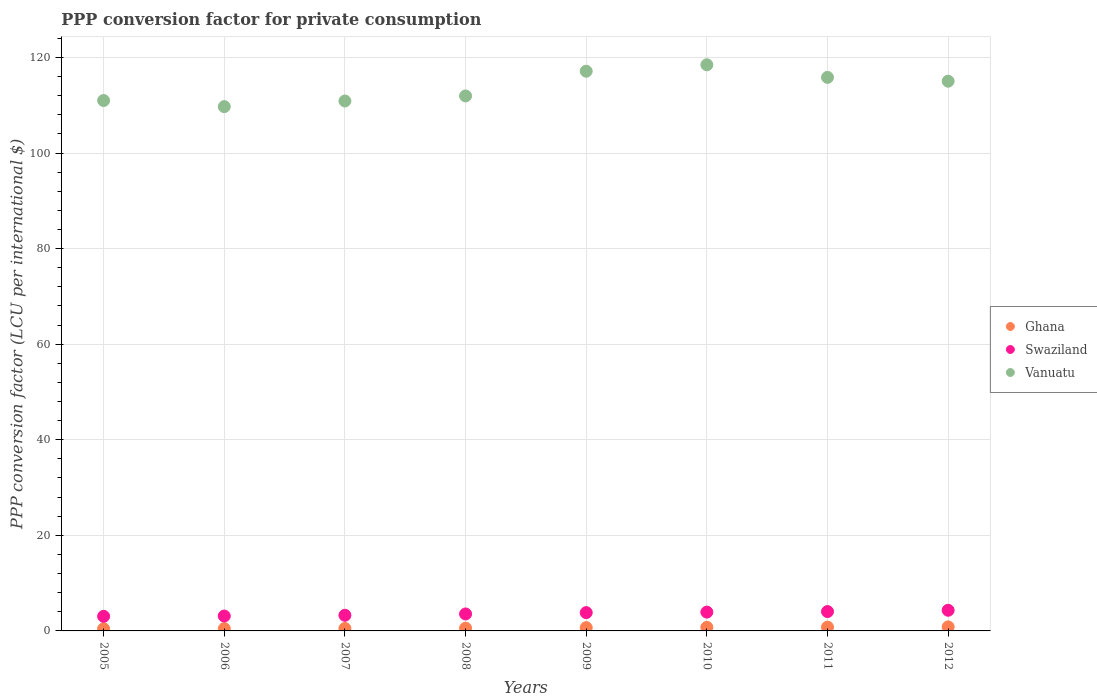Is the number of dotlines equal to the number of legend labels?
Make the answer very short. Yes. What is the PPP conversion factor for private consumption in Ghana in 2009?
Your answer should be very brief. 0.69. Across all years, what is the maximum PPP conversion factor for private consumption in Swaziland?
Your response must be concise. 4.32. Across all years, what is the minimum PPP conversion factor for private consumption in Ghana?
Your response must be concise. 0.44. In which year was the PPP conversion factor for private consumption in Swaziland minimum?
Offer a very short reply. 2005. What is the total PPP conversion factor for private consumption in Swaziland in the graph?
Offer a very short reply. 29.13. What is the difference between the PPP conversion factor for private consumption in Vanuatu in 2005 and that in 2011?
Provide a short and direct response. -4.85. What is the difference between the PPP conversion factor for private consumption in Swaziland in 2006 and the PPP conversion factor for private consumption in Ghana in 2005?
Your answer should be compact. 2.67. What is the average PPP conversion factor for private consumption in Swaziland per year?
Provide a short and direct response. 3.64. In the year 2011, what is the difference between the PPP conversion factor for private consumption in Ghana and PPP conversion factor for private consumption in Vanuatu?
Give a very brief answer. -115.04. In how many years, is the PPP conversion factor for private consumption in Swaziland greater than 36 LCU?
Your answer should be very brief. 0. What is the ratio of the PPP conversion factor for private consumption in Vanuatu in 2006 to that in 2012?
Your answer should be very brief. 0.95. What is the difference between the highest and the second highest PPP conversion factor for private consumption in Ghana?
Keep it short and to the point. 0.05. What is the difference between the highest and the lowest PPP conversion factor for private consumption in Swaziland?
Ensure brevity in your answer.  1.27. In how many years, is the PPP conversion factor for private consumption in Vanuatu greater than the average PPP conversion factor for private consumption in Vanuatu taken over all years?
Give a very brief answer. 4. Is it the case that in every year, the sum of the PPP conversion factor for private consumption in Ghana and PPP conversion factor for private consumption in Swaziland  is greater than the PPP conversion factor for private consumption in Vanuatu?
Give a very brief answer. No. Does the PPP conversion factor for private consumption in Ghana monotonically increase over the years?
Make the answer very short. Yes. Is the PPP conversion factor for private consumption in Vanuatu strictly greater than the PPP conversion factor for private consumption in Swaziland over the years?
Provide a succinct answer. Yes. Is the PPP conversion factor for private consumption in Swaziland strictly less than the PPP conversion factor for private consumption in Vanuatu over the years?
Your answer should be very brief. Yes. How many dotlines are there?
Offer a terse response. 3. Does the graph contain grids?
Ensure brevity in your answer.  Yes. Where does the legend appear in the graph?
Keep it short and to the point. Center right. How many legend labels are there?
Provide a succinct answer. 3. What is the title of the graph?
Provide a short and direct response. PPP conversion factor for private consumption. What is the label or title of the Y-axis?
Keep it short and to the point. PPP conversion factor (LCU per international $). What is the PPP conversion factor (LCU per international $) in Ghana in 2005?
Your answer should be compact. 0.44. What is the PPP conversion factor (LCU per international $) of Swaziland in 2005?
Provide a succinct answer. 3.05. What is the PPP conversion factor (LCU per international $) in Vanuatu in 2005?
Provide a short and direct response. 110.98. What is the PPP conversion factor (LCU per international $) of Ghana in 2006?
Provide a short and direct response. 0.47. What is the PPP conversion factor (LCU per international $) of Swaziland in 2006?
Offer a very short reply. 3.11. What is the PPP conversion factor (LCU per international $) of Vanuatu in 2006?
Offer a terse response. 109.71. What is the PPP conversion factor (LCU per international $) of Ghana in 2007?
Provide a succinct answer. 0.51. What is the PPP conversion factor (LCU per international $) of Swaziland in 2007?
Give a very brief answer. 3.27. What is the PPP conversion factor (LCU per international $) of Vanuatu in 2007?
Offer a very short reply. 110.88. What is the PPP conversion factor (LCU per international $) in Ghana in 2008?
Offer a very short reply. 0.57. What is the PPP conversion factor (LCU per international $) in Swaziland in 2008?
Give a very brief answer. 3.55. What is the PPP conversion factor (LCU per international $) in Vanuatu in 2008?
Make the answer very short. 111.94. What is the PPP conversion factor (LCU per international $) of Ghana in 2009?
Offer a terse response. 0.69. What is the PPP conversion factor (LCU per international $) of Swaziland in 2009?
Provide a short and direct response. 3.83. What is the PPP conversion factor (LCU per international $) of Vanuatu in 2009?
Offer a very short reply. 117.11. What is the PPP conversion factor (LCU per international $) of Ghana in 2010?
Your answer should be very brief. 0.75. What is the PPP conversion factor (LCU per international $) of Swaziland in 2010?
Your answer should be very brief. 3.94. What is the PPP conversion factor (LCU per international $) in Vanuatu in 2010?
Your answer should be very brief. 118.46. What is the PPP conversion factor (LCU per international $) of Ghana in 2011?
Your answer should be very brief. 0.79. What is the PPP conversion factor (LCU per international $) of Swaziland in 2011?
Make the answer very short. 4.05. What is the PPP conversion factor (LCU per international $) in Vanuatu in 2011?
Make the answer very short. 115.83. What is the PPP conversion factor (LCU per international $) in Ghana in 2012?
Your response must be concise. 0.84. What is the PPP conversion factor (LCU per international $) of Swaziland in 2012?
Provide a succinct answer. 4.32. What is the PPP conversion factor (LCU per international $) of Vanuatu in 2012?
Provide a succinct answer. 115.03. Across all years, what is the maximum PPP conversion factor (LCU per international $) of Ghana?
Offer a terse response. 0.84. Across all years, what is the maximum PPP conversion factor (LCU per international $) in Swaziland?
Keep it short and to the point. 4.32. Across all years, what is the maximum PPP conversion factor (LCU per international $) in Vanuatu?
Provide a short and direct response. 118.46. Across all years, what is the minimum PPP conversion factor (LCU per international $) of Ghana?
Your answer should be compact. 0.44. Across all years, what is the minimum PPP conversion factor (LCU per international $) of Swaziland?
Give a very brief answer. 3.05. Across all years, what is the minimum PPP conversion factor (LCU per international $) of Vanuatu?
Offer a very short reply. 109.71. What is the total PPP conversion factor (LCU per international $) in Ghana in the graph?
Keep it short and to the point. 5.07. What is the total PPP conversion factor (LCU per international $) in Swaziland in the graph?
Provide a succinct answer. 29.13. What is the total PPP conversion factor (LCU per international $) of Vanuatu in the graph?
Keep it short and to the point. 909.94. What is the difference between the PPP conversion factor (LCU per international $) of Ghana in 2005 and that in 2006?
Make the answer very short. -0.03. What is the difference between the PPP conversion factor (LCU per international $) of Swaziland in 2005 and that in 2006?
Your answer should be compact. -0.06. What is the difference between the PPP conversion factor (LCU per international $) in Vanuatu in 2005 and that in 2006?
Provide a short and direct response. 1.27. What is the difference between the PPP conversion factor (LCU per international $) of Ghana in 2005 and that in 2007?
Your response must be concise. -0.07. What is the difference between the PPP conversion factor (LCU per international $) of Swaziland in 2005 and that in 2007?
Provide a short and direct response. -0.22. What is the difference between the PPP conversion factor (LCU per international $) of Vanuatu in 2005 and that in 2007?
Give a very brief answer. 0.1. What is the difference between the PPP conversion factor (LCU per international $) in Ghana in 2005 and that in 2008?
Make the answer very short. -0.13. What is the difference between the PPP conversion factor (LCU per international $) of Swaziland in 2005 and that in 2008?
Keep it short and to the point. -0.5. What is the difference between the PPP conversion factor (LCU per international $) in Vanuatu in 2005 and that in 2008?
Keep it short and to the point. -0.96. What is the difference between the PPP conversion factor (LCU per international $) of Ghana in 2005 and that in 2009?
Your response must be concise. -0.24. What is the difference between the PPP conversion factor (LCU per international $) in Swaziland in 2005 and that in 2009?
Keep it short and to the point. -0.78. What is the difference between the PPP conversion factor (LCU per international $) in Vanuatu in 2005 and that in 2009?
Provide a succinct answer. -6.13. What is the difference between the PPP conversion factor (LCU per international $) in Ghana in 2005 and that in 2010?
Your response must be concise. -0.31. What is the difference between the PPP conversion factor (LCU per international $) of Swaziland in 2005 and that in 2010?
Offer a very short reply. -0.88. What is the difference between the PPP conversion factor (LCU per international $) of Vanuatu in 2005 and that in 2010?
Provide a short and direct response. -7.48. What is the difference between the PPP conversion factor (LCU per international $) in Ghana in 2005 and that in 2011?
Your response must be concise. -0.35. What is the difference between the PPP conversion factor (LCU per international $) of Swaziland in 2005 and that in 2011?
Offer a terse response. -1. What is the difference between the PPP conversion factor (LCU per international $) of Vanuatu in 2005 and that in 2011?
Make the answer very short. -4.85. What is the difference between the PPP conversion factor (LCU per international $) of Ghana in 2005 and that in 2012?
Offer a terse response. -0.4. What is the difference between the PPP conversion factor (LCU per international $) of Swaziland in 2005 and that in 2012?
Your response must be concise. -1.27. What is the difference between the PPP conversion factor (LCU per international $) of Vanuatu in 2005 and that in 2012?
Your answer should be compact. -4.05. What is the difference between the PPP conversion factor (LCU per international $) of Ghana in 2006 and that in 2007?
Provide a short and direct response. -0.04. What is the difference between the PPP conversion factor (LCU per international $) of Swaziland in 2006 and that in 2007?
Give a very brief answer. -0.16. What is the difference between the PPP conversion factor (LCU per international $) in Vanuatu in 2006 and that in 2007?
Your answer should be very brief. -1.18. What is the difference between the PPP conversion factor (LCU per international $) in Ghana in 2006 and that in 2008?
Keep it short and to the point. -0.1. What is the difference between the PPP conversion factor (LCU per international $) of Swaziland in 2006 and that in 2008?
Your response must be concise. -0.44. What is the difference between the PPP conversion factor (LCU per international $) in Vanuatu in 2006 and that in 2008?
Ensure brevity in your answer.  -2.23. What is the difference between the PPP conversion factor (LCU per international $) of Ghana in 2006 and that in 2009?
Your answer should be very brief. -0.21. What is the difference between the PPP conversion factor (LCU per international $) of Swaziland in 2006 and that in 2009?
Your answer should be very brief. -0.71. What is the difference between the PPP conversion factor (LCU per international $) of Vanuatu in 2006 and that in 2009?
Give a very brief answer. -7.41. What is the difference between the PPP conversion factor (LCU per international $) in Ghana in 2006 and that in 2010?
Provide a short and direct response. -0.27. What is the difference between the PPP conversion factor (LCU per international $) in Swaziland in 2006 and that in 2010?
Your answer should be very brief. -0.82. What is the difference between the PPP conversion factor (LCU per international $) in Vanuatu in 2006 and that in 2010?
Give a very brief answer. -8.75. What is the difference between the PPP conversion factor (LCU per international $) in Ghana in 2006 and that in 2011?
Make the answer very short. -0.31. What is the difference between the PPP conversion factor (LCU per international $) in Swaziland in 2006 and that in 2011?
Keep it short and to the point. -0.93. What is the difference between the PPP conversion factor (LCU per international $) in Vanuatu in 2006 and that in 2011?
Your response must be concise. -6.12. What is the difference between the PPP conversion factor (LCU per international $) of Ghana in 2006 and that in 2012?
Provide a short and direct response. -0.37. What is the difference between the PPP conversion factor (LCU per international $) of Swaziland in 2006 and that in 2012?
Your answer should be very brief. -1.21. What is the difference between the PPP conversion factor (LCU per international $) of Vanuatu in 2006 and that in 2012?
Your answer should be very brief. -5.32. What is the difference between the PPP conversion factor (LCU per international $) of Ghana in 2007 and that in 2008?
Ensure brevity in your answer.  -0.06. What is the difference between the PPP conversion factor (LCU per international $) in Swaziland in 2007 and that in 2008?
Provide a short and direct response. -0.28. What is the difference between the PPP conversion factor (LCU per international $) in Vanuatu in 2007 and that in 2008?
Ensure brevity in your answer.  -1.06. What is the difference between the PPP conversion factor (LCU per international $) of Ghana in 2007 and that in 2009?
Offer a very short reply. -0.18. What is the difference between the PPP conversion factor (LCU per international $) of Swaziland in 2007 and that in 2009?
Keep it short and to the point. -0.56. What is the difference between the PPP conversion factor (LCU per international $) of Vanuatu in 2007 and that in 2009?
Give a very brief answer. -6.23. What is the difference between the PPP conversion factor (LCU per international $) in Ghana in 2007 and that in 2010?
Make the answer very short. -0.24. What is the difference between the PPP conversion factor (LCU per international $) in Swaziland in 2007 and that in 2010?
Keep it short and to the point. -0.66. What is the difference between the PPP conversion factor (LCU per international $) in Vanuatu in 2007 and that in 2010?
Keep it short and to the point. -7.58. What is the difference between the PPP conversion factor (LCU per international $) of Ghana in 2007 and that in 2011?
Keep it short and to the point. -0.28. What is the difference between the PPP conversion factor (LCU per international $) of Swaziland in 2007 and that in 2011?
Offer a terse response. -0.78. What is the difference between the PPP conversion factor (LCU per international $) in Vanuatu in 2007 and that in 2011?
Provide a succinct answer. -4.94. What is the difference between the PPP conversion factor (LCU per international $) in Ghana in 2007 and that in 2012?
Offer a terse response. -0.33. What is the difference between the PPP conversion factor (LCU per international $) of Swaziland in 2007 and that in 2012?
Offer a terse response. -1.05. What is the difference between the PPP conversion factor (LCU per international $) in Vanuatu in 2007 and that in 2012?
Your answer should be compact. -4.14. What is the difference between the PPP conversion factor (LCU per international $) of Ghana in 2008 and that in 2009?
Ensure brevity in your answer.  -0.11. What is the difference between the PPP conversion factor (LCU per international $) of Swaziland in 2008 and that in 2009?
Your answer should be compact. -0.28. What is the difference between the PPP conversion factor (LCU per international $) in Vanuatu in 2008 and that in 2009?
Provide a succinct answer. -5.17. What is the difference between the PPP conversion factor (LCU per international $) of Ghana in 2008 and that in 2010?
Your answer should be compact. -0.17. What is the difference between the PPP conversion factor (LCU per international $) in Swaziland in 2008 and that in 2010?
Provide a short and direct response. -0.39. What is the difference between the PPP conversion factor (LCU per international $) in Vanuatu in 2008 and that in 2010?
Your answer should be compact. -6.52. What is the difference between the PPP conversion factor (LCU per international $) in Ghana in 2008 and that in 2011?
Your response must be concise. -0.21. What is the difference between the PPP conversion factor (LCU per international $) of Swaziland in 2008 and that in 2011?
Make the answer very short. -0.5. What is the difference between the PPP conversion factor (LCU per international $) in Vanuatu in 2008 and that in 2011?
Give a very brief answer. -3.89. What is the difference between the PPP conversion factor (LCU per international $) in Ghana in 2008 and that in 2012?
Offer a very short reply. -0.27. What is the difference between the PPP conversion factor (LCU per international $) in Swaziland in 2008 and that in 2012?
Keep it short and to the point. -0.77. What is the difference between the PPP conversion factor (LCU per international $) of Vanuatu in 2008 and that in 2012?
Make the answer very short. -3.09. What is the difference between the PPP conversion factor (LCU per international $) in Ghana in 2009 and that in 2010?
Offer a terse response. -0.06. What is the difference between the PPP conversion factor (LCU per international $) in Swaziland in 2009 and that in 2010?
Offer a very short reply. -0.11. What is the difference between the PPP conversion factor (LCU per international $) in Vanuatu in 2009 and that in 2010?
Ensure brevity in your answer.  -1.35. What is the difference between the PPP conversion factor (LCU per international $) of Ghana in 2009 and that in 2011?
Ensure brevity in your answer.  -0.1. What is the difference between the PPP conversion factor (LCU per international $) in Swaziland in 2009 and that in 2011?
Offer a terse response. -0.22. What is the difference between the PPP conversion factor (LCU per international $) of Vanuatu in 2009 and that in 2011?
Your answer should be compact. 1.29. What is the difference between the PPP conversion factor (LCU per international $) in Ghana in 2009 and that in 2012?
Ensure brevity in your answer.  -0.16. What is the difference between the PPP conversion factor (LCU per international $) of Swaziland in 2009 and that in 2012?
Provide a short and direct response. -0.49. What is the difference between the PPP conversion factor (LCU per international $) of Vanuatu in 2009 and that in 2012?
Provide a short and direct response. 2.09. What is the difference between the PPP conversion factor (LCU per international $) of Ghana in 2010 and that in 2011?
Your answer should be very brief. -0.04. What is the difference between the PPP conversion factor (LCU per international $) of Swaziland in 2010 and that in 2011?
Give a very brief answer. -0.11. What is the difference between the PPP conversion factor (LCU per international $) of Vanuatu in 2010 and that in 2011?
Give a very brief answer. 2.63. What is the difference between the PPP conversion factor (LCU per international $) in Ghana in 2010 and that in 2012?
Provide a succinct answer. -0.1. What is the difference between the PPP conversion factor (LCU per international $) of Swaziland in 2010 and that in 2012?
Provide a succinct answer. -0.39. What is the difference between the PPP conversion factor (LCU per international $) in Vanuatu in 2010 and that in 2012?
Make the answer very short. 3.44. What is the difference between the PPP conversion factor (LCU per international $) of Ghana in 2011 and that in 2012?
Offer a terse response. -0.05. What is the difference between the PPP conversion factor (LCU per international $) in Swaziland in 2011 and that in 2012?
Provide a succinct answer. -0.27. What is the difference between the PPP conversion factor (LCU per international $) of Vanuatu in 2011 and that in 2012?
Offer a terse response. 0.8. What is the difference between the PPP conversion factor (LCU per international $) in Ghana in 2005 and the PPP conversion factor (LCU per international $) in Swaziland in 2006?
Keep it short and to the point. -2.67. What is the difference between the PPP conversion factor (LCU per international $) in Ghana in 2005 and the PPP conversion factor (LCU per international $) in Vanuatu in 2006?
Make the answer very short. -109.27. What is the difference between the PPP conversion factor (LCU per international $) in Swaziland in 2005 and the PPP conversion factor (LCU per international $) in Vanuatu in 2006?
Your response must be concise. -106.65. What is the difference between the PPP conversion factor (LCU per international $) of Ghana in 2005 and the PPP conversion factor (LCU per international $) of Swaziland in 2007?
Your response must be concise. -2.83. What is the difference between the PPP conversion factor (LCU per international $) of Ghana in 2005 and the PPP conversion factor (LCU per international $) of Vanuatu in 2007?
Make the answer very short. -110.44. What is the difference between the PPP conversion factor (LCU per international $) of Swaziland in 2005 and the PPP conversion factor (LCU per international $) of Vanuatu in 2007?
Your response must be concise. -107.83. What is the difference between the PPP conversion factor (LCU per international $) in Ghana in 2005 and the PPP conversion factor (LCU per international $) in Swaziland in 2008?
Your response must be concise. -3.11. What is the difference between the PPP conversion factor (LCU per international $) of Ghana in 2005 and the PPP conversion factor (LCU per international $) of Vanuatu in 2008?
Your answer should be very brief. -111.5. What is the difference between the PPP conversion factor (LCU per international $) of Swaziland in 2005 and the PPP conversion factor (LCU per international $) of Vanuatu in 2008?
Your response must be concise. -108.89. What is the difference between the PPP conversion factor (LCU per international $) of Ghana in 2005 and the PPP conversion factor (LCU per international $) of Swaziland in 2009?
Your answer should be very brief. -3.39. What is the difference between the PPP conversion factor (LCU per international $) of Ghana in 2005 and the PPP conversion factor (LCU per international $) of Vanuatu in 2009?
Your response must be concise. -116.67. What is the difference between the PPP conversion factor (LCU per international $) in Swaziland in 2005 and the PPP conversion factor (LCU per international $) in Vanuatu in 2009?
Offer a terse response. -114.06. What is the difference between the PPP conversion factor (LCU per international $) of Ghana in 2005 and the PPP conversion factor (LCU per international $) of Swaziland in 2010?
Offer a terse response. -3.49. What is the difference between the PPP conversion factor (LCU per international $) of Ghana in 2005 and the PPP conversion factor (LCU per international $) of Vanuatu in 2010?
Your answer should be compact. -118.02. What is the difference between the PPP conversion factor (LCU per international $) in Swaziland in 2005 and the PPP conversion factor (LCU per international $) in Vanuatu in 2010?
Offer a very short reply. -115.41. What is the difference between the PPP conversion factor (LCU per international $) of Ghana in 2005 and the PPP conversion factor (LCU per international $) of Swaziland in 2011?
Ensure brevity in your answer.  -3.61. What is the difference between the PPP conversion factor (LCU per international $) of Ghana in 2005 and the PPP conversion factor (LCU per international $) of Vanuatu in 2011?
Provide a succinct answer. -115.39. What is the difference between the PPP conversion factor (LCU per international $) of Swaziland in 2005 and the PPP conversion factor (LCU per international $) of Vanuatu in 2011?
Keep it short and to the point. -112.77. What is the difference between the PPP conversion factor (LCU per international $) of Ghana in 2005 and the PPP conversion factor (LCU per international $) of Swaziland in 2012?
Give a very brief answer. -3.88. What is the difference between the PPP conversion factor (LCU per international $) in Ghana in 2005 and the PPP conversion factor (LCU per international $) in Vanuatu in 2012?
Keep it short and to the point. -114.58. What is the difference between the PPP conversion factor (LCU per international $) in Swaziland in 2005 and the PPP conversion factor (LCU per international $) in Vanuatu in 2012?
Ensure brevity in your answer.  -111.97. What is the difference between the PPP conversion factor (LCU per international $) in Ghana in 2006 and the PPP conversion factor (LCU per international $) in Swaziland in 2007?
Keep it short and to the point. -2.8. What is the difference between the PPP conversion factor (LCU per international $) in Ghana in 2006 and the PPP conversion factor (LCU per international $) in Vanuatu in 2007?
Offer a terse response. -110.41. What is the difference between the PPP conversion factor (LCU per international $) of Swaziland in 2006 and the PPP conversion factor (LCU per international $) of Vanuatu in 2007?
Provide a succinct answer. -107.77. What is the difference between the PPP conversion factor (LCU per international $) in Ghana in 2006 and the PPP conversion factor (LCU per international $) in Swaziland in 2008?
Provide a short and direct response. -3.08. What is the difference between the PPP conversion factor (LCU per international $) of Ghana in 2006 and the PPP conversion factor (LCU per international $) of Vanuatu in 2008?
Make the answer very short. -111.47. What is the difference between the PPP conversion factor (LCU per international $) in Swaziland in 2006 and the PPP conversion factor (LCU per international $) in Vanuatu in 2008?
Offer a terse response. -108.83. What is the difference between the PPP conversion factor (LCU per international $) in Ghana in 2006 and the PPP conversion factor (LCU per international $) in Swaziland in 2009?
Your answer should be compact. -3.35. What is the difference between the PPP conversion factor (LCU per international $) of Ghana in 2006 and the PPP conversion factor (LCU per international $) of Vanuatu in 2009?
Offer a terse response. -116.64. What is the difference between the PPP conversion factor (LCU per international $) in Swaziland in 2006 and the PPP conversion factor (LCU per international $) in Vanuatu in 2009?
Ensure brevity in your answer.  -114. What is the difference between the PPP conversion factor (LCU per international $) of Ghana in 2006 and the PPP conversion factor (LCU per international $) of Swaziland in 2010?
Offer a very short reply. -3.46. What is the difference between the PPP conversion factor (LCU per international $) of Ghana in 2006 and the PPP conversion factor (LCU per international $) of Vanuatu in 2010?
Your answer should be compact. -117.99. What is the difference between the PPP conversion factor (LCU per international $) of Swaziland in 2006 and the PPP conversion factor (LCU per international $) of Vanuatu in 2010?
Keep it short and to the point. -115.35. What is the difference between the PPP conversion factor (LCU per international $) of Ghana in 2006 and the PPP conversion factor (LCU per international $) of Swaziland in 2011?
Offer a terse response. -3.57. What is the difference between the PPP conversion factor (LCU per international $) in Ghana in 2006 and the PPP conversion factor (LCU per international $) in Vanuatu in 2011?
Your answer should be compact. -115.35. What is the difference between the PPP conversion factor (LCU per international $) of Swaziland in 2006 and the PPP conversion factor (LCU per international $) of Vanuatu in 2011?
Offer a very short reply. -112.71. What is the difference between the PPP conversion factor (LCU per international $) of Ghana in 2006 and the PPP conversion factor (LCU per international $) of Swaziland in 2012?
Your response must be concise. -3.85. What is the difference between the PPP conversion factor (LCU per international $) of Ghana in 2006 and the PPP conversion factor (LCU per international $) of Vanuatu in 2012?
Make the answer very short. -114.55. What is the difference between the PPP conversion factor (LCU per international $) in Swaziland in 2006 and the PPP conversion factor (LCU per international $) in Vanuatu in 2012?
Offer a very short reply. -111.91. What is the difference between the PPP conversion factor (LCU per international $) of Ghana in 2007 and the PPP conversion factor (LCU per international $) of Swaziland in 2008?
Make the answer very short. -3.04. What is the difference between the PPP conversion factor (LCU per international $) in Ghana in 2007 and the PPP conversion factor (LCU per international $) in Vanuatu in 2008?
Give a very brief answer. -111.43. What is the difference between the PPP conversion factor (LCU per international $) in Swaziland in 2007 and the PPP conversion factor (LCU per international $) in Vanuatu in 2008?
Make the answer very short. -108.67. What is the difference between the PPP conversion factor (LCU per international $) in Ghana in 2007 and the PPP conversion factor (LCU per international $) in Swaziland in 2009?
Make the answer very short. -3.32. What is the difference between the PPP conversion factor (LCU per international $) of Ghana in 2007 and the PPP conversion factor (LCU per international $) of Vanuatu in 2009?
Your answer should be compact. -116.6. What is the difference between the PPP conversion factor (LCU per international $) in Swaziland in 2007 and the PPP conversion factor (LCU per international $) in Vanuatu in 2009?
Keep it short and to the point. -113.84. What is the difference between the PPP conversion factor (LCU per international $) in Ghana in 2007 and the PPP conversion factor (LCU per international $) in Swaziland in 2010?
Offer a terse response. -3.43. What is the difference between the PPP conversion factor (LCU per international $) of Ghana in 2007 and the PPP conversion factor (LCU per international $) of Vanuatu in 2010?
Provide a short and direct response. -117.95. What is the difference between the PPP conversion factor (LCU per international $) in Swaziland in 2007 and the PPP conversion factor (LCU per international $) in Vanuatu in 2010?
Your response must be concise. -115.19. What is the difference between the PPP conversion factor (LCU per international $) of Ghana in 2007 and the PPP conversion factor (LCU per international $) of Swaziland in 2011?
Provide a short and direct response. -3.54. What is the difference between the PPP conversion factor (LCU per international $) of Ghana in 2007 and the PPP conversion factor (LCU per international $) of Vanuatu in 2011?
Make the answer very short. -115.32. What is the difference between the PPP conversion factor (LCU per international $) in Swaziland in 2007 and the PPP conversion factor (LCU per international $) in Vanuatu in 2011?
Ensure brevity in your answer.  -112.55. What is the difference between the PPP conversion factor (LCU per international $) in Ghana in 2007 and the PPP conversion factor (LCU per international $) in Swaziland in 2012?
Offer a very short reply. -3.81. What is the difference between the PPP conversion factor (LCU per international $) in Ghana in 2007 and the PPP conversion factor (LCU per international $) in Vanuatu in 2012?
Keep it short and to the point. -114.52. What is the difference between the PPP conversion factor (LCU per international $) in Swaziland in 2007 and the PPP conversion factor (LCU per international $) in Vanuatu in 2012?
Your answer should be very brief. -111.75. What is the difference between the PPP conversion factor (LCU per international $) in Ghana in 2008 and the PPP conversion factor (LCU per international $) in Swaziland in 2009?
Your response must be concise. -3.25. What is the difference between the PPP conversion factor (LCU per international $) in Ghana in 2008 and the PPP conversion factor (LCU per international $) in Vanuatu in 2009?
Give a very brief answer. -116.54. What is the difference between the PPP conversion factor (LCU per international $) of Swaziland in 2008 and the PPP conversion factor (LCU per international $) of Vanuatu in 2009?
Give a very brief answer. -113.56. What is the difference between the PPP conversion factor (LCU per international $) of Ghana in 2008 and the PPP conversion factor (LCU per international $) of Swaziland in 2010?
Provide a short and direct response. -3.36. What is the difference between the PPP conversion factor (LCU per international $) in Ghana in 2008 and the PPP conversion factor (LCU per international $) in Vanuatu in 2010?
Give a very brief answer. -117.89. What is the difference between the PPP conversion factor (LCU per international $) in Swaziland in 2008 and the PPP conversion factor (LCU per international $) in Vanuatu in 2010?
Your answer should be very brief. -114.91. What is the difference between the PPP conversion factor (LCU per international $) in Ghana in 2008 and the PPP conversion factor (LCU per international $) in Swaziland in 2011?
Your response must be concise. -3.48. What is the difference between the PPP conversion factor (LCU per international $) of Ghana in 2008 and the PPP conversion factor (LCU per international $) of Vanuatu in 2011?
Provide a short and direct response. -115.25. What is the difference between the PPP conversion factor (LCU per international $) in Swaziland in 2008 and the PPP conversion factor (LCU per international $) in Vanuatu in 2011?
Provide a succinct answer. -112.28. What is the difference between the PPP conversion factor (LCU per international $) of Ghana in 2008 and the PPP conversion factor (LCU per international $) of Swaziland in 2012?
Keep it short and to the point. -3.75. What is the difference between the PPP conversion factor (LCU per international $) of Ghana in 2008 and the PPP conversion factor (LCU per international $) of Vanuatu in 2012?
Keep it short and to the point. -114.45. What is the difference between the PPP conversion factor (LCU per international $) of Swaziland in 2008 and the PPP conversion factor (LCU per international $) of Vanuatu in 2012?
Offer a terse response. -111.48. What is the difference between the PPP conversion factor (LCU per international $) of Ghana in 2009 and the PPP conversion factor (LCU per international $) of Swaziland in 2010?
Provide a succinct answer. -3.25. What is the difference between the PPP conversion factor (LCU per international $) of Ghana in 2009 and the PPP conversion factor (LCU per international $) of Vanuatu in 2010?
Keep it short and to the point. -117.78. What is the difference between the PPP conversion factor (LCU per international $) in Swaziland in 2009 and the PPP conversion factor (LCU per international $) in Vanuatu in 2010?
Make the answer very short. -114.63. What is the difference between the PPP conversion factor (LCU per international $) in Ghana in 2009 and the PPP conversion factor (LCU per international $) in Swaziland in 2011?
Provide a short and direct response. -3.36. What is the difference between the PPP conversion factor (LCU per international $) of Ghana in 2009 and the PPP conversion factor (LCU per international $) of Vanuatu in 2011?
Offer a very short reply. -115.14. What is the difference between the PPP conversion factor (LCU per international $) of Swaziland in 2009 and the PPP conversion factor (LCU per international $) of Vanuatu in 2011?
Provide a short and direct response. -112. What is the difference between the PPP conversion factor (LCU per international $) of Ghana in 2009 and the PPP conversion factor (LCU per international $) of Swaziland in 2012?
Provide a short and direct response. -3.64. What is the difference between the PPP conversion factor (LCU per international $) of Ghana in 2009 and the PPP conversion factor (LCU per international $) of Vanuatu in 2012?
Ensure brevity in your answer.  -114.34. What is the difference between the PPP conversion factor (LCU per international $) in Swaziland in 2009 and the PPP conversion factor (LCU per international $) in Vanuatu in 2012?
Make the answer very short. -111.2. What is the difference between the PPP conversion factor (LCU per international $) of Ghana in 2010 and the PPP conversion factor (LCU per international $) of Swaziland in 2011?
Your answer should be very brief. -3.3. What is the difference between the PPP conversion factor (LCU per international $) of Ghana in 2010 and the PPP conversion factor (LCU per international $) of Vanuatu in 2011?
Your answer should be very brief. -115.08. What is the difference between the PPP conversion factor (LCU per international $) in Swaziland in 2010 and the PPP conversion factor (LCU per international $) in Vanuatu in 2011?
Give a very brief answer. -111.89. What is the difference between the PPP conversion factor (LCU per international $) of Ghana in 2010 and the PPP conversion factor (LCU per international $) of Swaziland in 2012?
Ensure brevity in your answer.  -3.57. What is the difference between the PPP conversion factor (LCU per international $) of Ghana in 2010 and the PPP conversion factor (LCU per international $) of Vanuatu in 2012?
Keep it short and to the point. -114.28. What is the difference between the PPP conversion factor (LCU per international $) of Swaziland in 2010 and the PPP conversion factor (LCU per international $) of Vanuatu in 2012?
Make the answer very short. -111.09. What is the difference between the PPP conversion factor (LCU per international $) in Ghana in 2011 and the PPP conversion factor (LCU per international $) in Swaziland in 2012?
Make the answer very short. -3.53. What is the difference between the PPP conversion factor (LCU per international $) of Ghana in 2011 and the PPP conversion factor (LCU per international $) of Vanuatu in 2012?
Your response must be concise. -114.24. What is the difference between the PPP conversion factor (LCU per international $) of Swaziland in 2011 and the PPP conversion factor (LCU per international $) of Vanuatu in 2012?
Provide a short and direct response. -110.98. What is the average PPP conversion factor (LCU per international $) in Ghana per year?
Keep it short and to the point. 0.63. What is the average PPP conversion factor (LCU per international $) in Swaziland per year?
Your response must be concise. 3.64. What is the average PPP conversion factor (LCU per international $) in Vanuatu per year?
Give a very brief answer. 113.74. In the year 2005, what is the difference between the PPP conversion factor (LCU per international $) of Ghana and PPP conversion factor (LCU per international $) of Swaziland?
Your answer should be very brief. -2.61. In the year 2005, what is the difference between the PPP conversion factor (LCU per international $) of Ghana and PPP conversion factor (LCU per international $) of Vanuatu?
Your answer should be very brief. -110.54. In the year 2005, what is the difference between the PPP conversion factor (LCU per international $) of Swaziland and PPP conversion factor (LCU per international $) of Vanuatu?
Offer a very short reply. -107.93. In the year 2006, what is the difference between the PPP conversion factor (LCU per international $) of Ghana and PPP conversion factor (LCU per international $) of Swaziland?
Provide a succinct answer. -2.64. In the year 2006, what is the difference between the PPP conversion factor (LCU per international $) of Ghana and PPP conversion factor (LCU per international $) of Vanuatu?
Offer a terse response. -109.23. In the year 2006, what is the difference between the PPP conversion factor (LCU per international $) of Swaziland and PPP conversion factor (LCU per international $) of Vanuatu?
Your answer should be very brief. -106.59. In the year 2007, what is the difference between the PPP conversion factor (LCU per international $) in Ghana and PPP conversion factor (LCU per international $) in Swaziland?
Ensure brevity in your answer.  -2.76. In the year 2007, what is the difference between the PPP conversion factor (LCU per international $) of Ghana and PPP conversion factor (LCU per international $) of Vanuatu?
Your response must be concise. -110.37. In the year 2007, what is the difference between the PPP conversion factor (LCU per international $) in Swaziland and PPP conversion factor (LCU per international $) in Vanuatu?
Give a very brief answer. -107.61. In the year 2008, what is the difference between the PPP conversion factor (LCU per international $) in Ghana and PPP conversion factor (LCU per international $) in Swaziland?
Provide a short and direct response. -2.98. In the year 2008, what is the difference between the PPP conversion factor (LCU per international $) of Ghana and PPP conversion factor (LCU per international $) of Vanuatu?
Provide a short and direct response. -111.37. In the year 2008, what is the difference between the PPP conversion factor (LCU per international $) in Swaziland and PPP conversion factor (LCU per international $) in Vanuatu?
Offer a terse response. -108.39. In the year 2009, what is the difference between the PPP conversion factor (LCU per international $) in Ghana and PPP conversion factor (LCU per international $) in Swaziland?
Your response must be concise. -3.14. In the year 2009, what is the difference between the PPP conversion factor (LCU per international $) in Ghana and PPP conversion factor (LCU per international $) in Vanuatu?
Your answer should be compact. -116.43. In the year 2009, what is the difference between the PPP conversion factor (LCU per international $) in Swaziland and PPP conversion factor (LCU per international $) in Vanuatu?
Offer a terse response. -113.29. In the year 2010, what is the difference between the PPP conversion factor (LCU per international $) in Ghana and PPP conversion factor (LCU per international $) in Swaziland?
Offer a terse response. -3.19. In the year 2010, what is the difference between the PPP conversion factor (LCU per international $) in Ghana and PPP conversion factor (LCU per international $) in Vanuatu?
Offer a very short reply. -117.71. In the year 2010, what is the difference between the PPP conversion factor (LCU per international $) of Swaziland and PPP conversion factor (LCU per international $) of Vanuatu?
Your answer should be very brief. -114.53. In the year 2011, what is the difference between the PPP conversion factor (LCU per international $) of Ghana and PPP conversion factor (LCU per international $) of Swaziland?
Your answer should be very brief. -3.26. In the year 2011, what is the difference between the PPP conversion factor (LCU per international $) of Ghana and PPP conversion factor (LCU per international $) of Vanuatu?
Offer a very short reply. -115.04. In the year 2011, what is the difference between the PPP conversion factor (LCU per international $) in Swaziland and PPP conversion factor (LCU per international $) in Vanuatu?
Give a very brief answer. -111.78. In the year 2012, what is the difference between the PPP conversion factor (LCU per international $) of Ghana and PPP conversion factor (LCU per international $) of Swaziland?
Keep it short and to the point. -3.48. In the year 2012, what is the difference between the PPP conversion factor (LCU per international $) of Ghana and PPP conversion factor (LCU per international $) of Vanuatu?
Your answer should be compact. -114.18. In the year 2012, what is the difference between the PPP conversion factor (LCU per international $) of Swaziland and PPP conversion factor (LCU per international $) of Vanuatu?
Offer a very short reply. -110.7. What is the ratio of the PPP conversion factor (LCU per international $) in Ghana in 2005 to that in 2006?
Provide a short and direct response. 0.93. What is the ratio of the PPP conversion factor (LCU per international $) of Swaziland in 2005 to that in 2006?
Make the answer very short. 0.98. What is the ratio of the PPP conversion factor (LCU per international $) in Vanuatu in 2005 to that in 2006?
Your answer should be very brief. 1.01. What is the ratio of the PPP conversion factor (LCU per international $) of Ghana in 2005 to that in 2007?
Give a very brief answer. 0.86. What is the ratio of the PPP conversion factor (LCU per international $) of Swaziland in 2005 to that in 2007?
Provide a succinct answer. 0.93. What is the ratio of the PPP conversion factor (LCU per international $) in Ghana in 2005 to that in 2008?
Provide a short and direct response. 0.77. What is the ratio of the PPP conversion factor (LCU per international $) in Swaziland in 2005 to that in 2008?
Offer a very short reply. 0.86. What is the ratio of the PPP conversion factor (LCU per international $) of Vanuatu in 2005 to that in 2008?
Provide a short and direct response. 0.99. What is the ratio of the PPP conversion factor (LCU per international $) in Ghana in 2005 to that in 2009?
Offer a terse response. 0.64. What is the ratio of the PPP conversion factor (LCU per international $) in Swaziland in 2005 to that in 2009?
Offer a terse response. 0.8. What is the ratio of the PPP conversion factor (LCU per international $) of Vanuatu in 2005 to that in 2009?
Give a very brief answer. 0.95. What is the ratio of the PPP conversion factor (LCU per international $) in Ghana in 2005 to that in 2010?
Give a very brief answer. 0.59. What is the ratio of the PPP conversion factor (LCU per international $) in Swaziland in 2005 to that in 2010?
Provide a short and direct response. 0.78. What is the ratio of the PPP conversion factor (LCU per international $) in Vanuatu in 2005 to that in 2010?
Ensure brevity in your answer.  0.94. What is the ratio of the PPP conversion factor (LCU per international $) of Ghana in 2005 to that in 2011?
Your answer should be very brief. 0.56. What is the ratio of the PPP conversion factor (LCU per international $) of Swaziland in 2005 to that in 2011?
Offer a very short reply. 0.75. What is the ratio of the PPP conversion factor (LCU per international $) of Vanuatu in 2005 to that in 2011?
Provide a short and direct response. 0.96. What is the ratio of the PPP conversion factor (LCU per international $) of Ghana in 2005 to that in 2012?
Offer a very short reply. 0.52. What is the ratio of the PPP conversion factor (LCU per international $) of Swaziland in 2005 to that in 2012?
Ensure brevity in your answer.  0.71. What is the ratio of the PPP conversion factor (LCU per international $) of Vanuatu in 2005 to that in 2012?
Your answer should be compact. 0.96. What is the ratio of the PPP conversion factor (LCU per international $) of Ghana in 2006 to that in 2007?
Make the answer very short. 0.93. What is the ratio of the PPP conversion factor (LCU per international $) in Swaziland in 2006 to that in 2007?
Your answer should be compact. 0.95. What is the ratio of the PPP conversion factor (LCU per international $) of Ghana in 2006 to that in 2008?
Give a very brief answer. 0.83. What is the ratio of the PPP conversion factor (LCU per international $) in Swaziland in 2006 to that in 2008?
Give a very brief answer. 0.88. What is the ratio of the PPP conversion factor (LCU per international $) of Vanuatu in 2006 to that in 2008?
Offer a terse response. 0.98. What is the ratio of the PPP conversion factor (LCU per international $) in Ghana in 2006 to that in 2009?
Offer a terse response. 0.69. What is the ratio of the PPP conversion factor (LCU per international $) in Swaziland in 2006 to that in 2009?
Your response must be concise. 0.81. What is the ratio of the PPP conversion factor (LCU per international $) in Vanuatu in 2006 to that in 2009?
Provide a short and direct response. 0.94. What is the ratio of the PPP conversion factor (LCU per international $) of Ghana in 2006 to that in 2010?
Give a very brief answer. 0.64. What is the ratio of the PPP conversion factor (LCU per international $) in Swaziland in 2006 to that in 2010?
Provide a succinct answer. 0.79. What is the ratio of the PPP conversion factor (LCU per international $) of Vanuatu in 2006 to that in 2010?
Your answer should be very brief. 0.93. What is the ratio of the PPP conversion factor (LCU per international $) in Ghana in 2006 to that in 2011?
Your answer should be compact. 0.6. What is the ratio of the PPP conversion factor (LCU per international $) of Swaziland in 2006 to that in 2011?
Your answer should be very brief. 0.77. What is the ratio of the PPP conversion factor (LCU per international $) of Vanuatu in 2006 to that in 2011?
Keep it short and to the point. 0.95. What is the ratio of the PPP conversion factor (LCU per international $) of Ghana in 2006 to that in 2012?
Ensure brevity in your answer.  0.56. What is the ratio of the PPP conversion factor (LCU per international $) in Swaziland in 2006 to that in 2012?
Your answer should be compact. 0.72. What is the ratio of the PPP conversion factor (LCU per international $) of Vanuatu in 2006 to that in 2012?
Provide a succinct answer. 0.95. What is the ratio of the PPP conversion factor (LCU per international $) in Ghana in 2007 to that in 2008?
Offer a terse response. 0.89. What is the ratio of the PPP conversion factor (LCU per international $) in Swaziland in 2007 to that in 2008?
Provide a succinct answer. 0.92. What is the ratio of the PPP conversion factor (LCU per international $) of Vanuatu in 2007 to that in 2008?
Make the answer very short. 0.99. What is the ratio of the PPP conversion factor (LCU per international $) in Ghana in 2007 to that in 2009?
Your answer should be compact. 0.74. What is the ratio of the PPP conversion factor (LCU per international $) of Swaziland in 2007 to that in 2009?
Your response must be concise. 0.85. What is the ratio of the PPP conversion factor (LCU per international $) in Vanuatu in 2007 to that in 2009?
Your answer should be compact. 0.95. What is the ratio of the PPP conversion factor (LCU per international $) of Ghana in 2007 to that in 2010?
Offer a very short reply. 0.68. What is the ratio of the PPP conversion factor (LCU per international $) of Swaziland in 2007 to that in 2010?
Your response must be concise. 0.83. What is the ratio of the PPP conversion factor (LCU per international $) in Vanuatu in 2007 to that in 2010?
Offer a very short reply. 0.94. What is the ratio of the PPP conversion factor (LCU per international $) of Ghana in 2007 to that in 2011?
Ensure brevity in your answer.  0.65. What is the ratio of the PPP conversion factor (LCU per international $) of Swaziland in 2007 to that in 2011?
Offer a terse response. 0.81. What is the ratio of the PPP conversion factor (LCU per international $) in Vanuatu in 2007 to that in 2011?
Give a very brief answer. 0.96. What is the ratio of the PPP conversion factor (LCU per international $) of Ghana in 2007 to that in 2012?
Keep it short and to the point. 0.61. What is the ratio of the PPP conversion factor (LCU per international $) in Swaziland in 2007 to that in 2012?
Your answer should be very brief. 0.76. What is the ratio of the PPP conversion factor (LCU per international $) of Ghana in 2008 to that in 2009?
Provide a short and direct response. 0.84. What is the ratio of the PPP conversion factor (LCU per international $) of Swaziland in 2008 to that in 2009?
Offer a terse response. 0.93. What is the ratio of the PPP conversion factor (LCU per international $) of Vanuatu in 2008 to that in 2009?
Make the answer very short. 0.96. What is the ratio of the PPP conversion factor (LCU per international $) in Ghana in 2008 to that in 2010?
Offer a terse response. 0.77. What is the ratio of the PPP conversion factor (LCU per international $) of Swaziland in 2008 to that in 2010?
Keep it short and to the point. 0.9. What is the ratio of the PPP conversion factor (LCU per international $) of Vanuatu in 2008 to that in 2010?
Offer a terse response. 0.94. What is the ratio of the PPP conversion factor (LCU per international $) of Ghana in 2008 to that in 2011?
Provide a succinct answer. 0.73. What is the ratio of the PPP conversion factor (LCU per international $) in Swaziland in 2008 to that in 2011?
Your answer should be compact. 0.88. What is the ratio of the PPP conversion factor (LCU per international $) in Vanuatu in 2008 to that in 2011?
Offer a terse response. 0.97. What is the ratio of the PPP conversion factor (LCU per international $) in Ghana in 2008 to that in 2012?
Offer a terse response. 0.68. What is the ratio of the PPP conversion factor (LCU per international $) of Swaziland in 2008 to that in 2012?
Offer a very short reply. 0.82. What is the ratio of the PPP conversion factor (LCU per international $) of Vanuatu in 2008 to that in 2012?
Give a very brief answer. 0.97. What is the ratio of the PPP conversion factor (LCU per international $) of Ghana in 2009 to that in 2010?
Offer a very short reply. 0.92. What is the ratio of the PPP conversion factor (LCU per international $) in Swaziland in 2009 to that in 2010?
Make the answer very short. 0.97. What is the ratio of the PPP conversion factor (LCU per international $) of Vanuatu in 2009 to that in 2010?
Provide a succinct answer. 0.99. What is the ratio of the PPP conversion factor (LCU per international $) of Ghana in 2009 to that in 2011?
Provide a succinct answer. 0.87. What is the ratio of the PPP conversion factor (LCU per international $) of Swaziland in 2009 to that in 2011?
Offer a terse response. 0.95. What is the ratio of the PPP conversion factor (LCU per international $) of Vanuatu in 2009 to that in 2011?
Make the answer very short. 1.01. What is the ratio of the PPP conversion factor (LCU per international $) of Ghana in 2009 to that in 2012?
Ensure brevity in your answer.  0.81. What is the ratio of the PPP conversion factor (LCU per international $) in Swaziland in 2009 to that in 2012?
Provide a short and direct response. 0.89. What is the ratio of the PPP conversion factor (LCU per international $) of Vanuatu in 2009 to that in 2012?
Ensure brevity in your answer.  1.02. What is the ratio of the PPP conversion factor (LCU per international $) of Ghana in 2010 to that in 2011?
Ensure brevity in your answer.  0.95. What is the ratio of the PPP conversion factor (LCU per international $) of Swaziland in 2010 to that in 2011?
Offer a very short reply. 0.97. What is the ratio of the PPP conversion factor (LCU per international $) of Vanuatu in 2010 to that in 2011?
Keep it short and to the point. 1.02. What is the ratio of the PPP conversion factor (LCU per international $) of Ghana in 2010 to that in 2012?
Offer a terse response. 0.89. What is the ratio of the PPP conversion factor (LCU per international $) of Swaziland in 2010 to that in 2012?
Provide a succinct answer. 0.91. What is the ratio of the PPP conversion factor (LCU per international $) in Vanuatu in 2010 to that in 2012?
Offer a terse response. 1.03. What is the ratio of the PPP conversion factor (LCU per international $) in Ghana in 2011 to that in 2012?
Offer a very short reply. 0.94. What is the ratio of the PPP conversion factor (LCU per international $) of Swaziland in 2011 to that in 2012?
Provide a short and direct response. 0.94. What is the ratio of the PPP conversion factor (LCU per international $) in Vanuatu in 2011 to that in 2012?
Offer a terse response. 1.01. What is the difference between the highest and the second highest PPP conversion factor (LCU per international $) in Ghana?
Offer a very short reply. 0.05. What is the difference between the highest and the second highest PPP conversion factor (LCU per international $) in Swaziland?
Keep it short and to the point. 0.27. What is the difference between the highest and the second highest PPP conversion factor (LCU per international $) in Vanuatu?
Offer a terse response. 1.35. What is the difference between the highest and the lowest PPP conversion factor (LCU per international $) of Ghana?
Ensure brevity in your answer.  0.4. What is the difference between the highest and the lowest PPP conversion factor (LCU per international $) of Swaziland?
Make the answer very short. 1.27. What is the difference between the highest and the lowest PPP conversion factor (LCU per international $) of Vanuatu?
Offer a terse response. 8.75. 